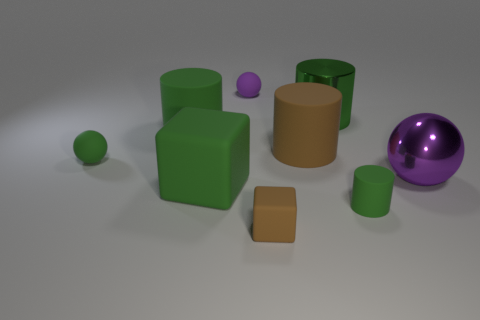What are the possible uses for the purple ball in the image? The purple ball, with its matte finish and size, could be a decorative element in a room, a prop for photographic composition, or part of a set of objects used to teach about colors and shapes. Could it be part of a game? Certainly, its size and visible texture make it suitable for games that involve rolling or throwing balls, such as indoor bowling or a sorting game. 